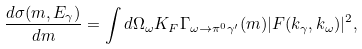Convert formula to latex. <formula><loc_0><loc_0><loc_500><loc_500>\frac { d \sigma ( m , E _ { \gamma } ) } { d m } = \int d \Omega _ { \omega } K _ { F } \Gamma _ { \omega \to \pi ^ { 0 } \gamma ^ { \prime } } ( m ) | F ( { k } _ { \gamma } , { k } _ { \omega } ) | ^ { 2 } ,</formula> 